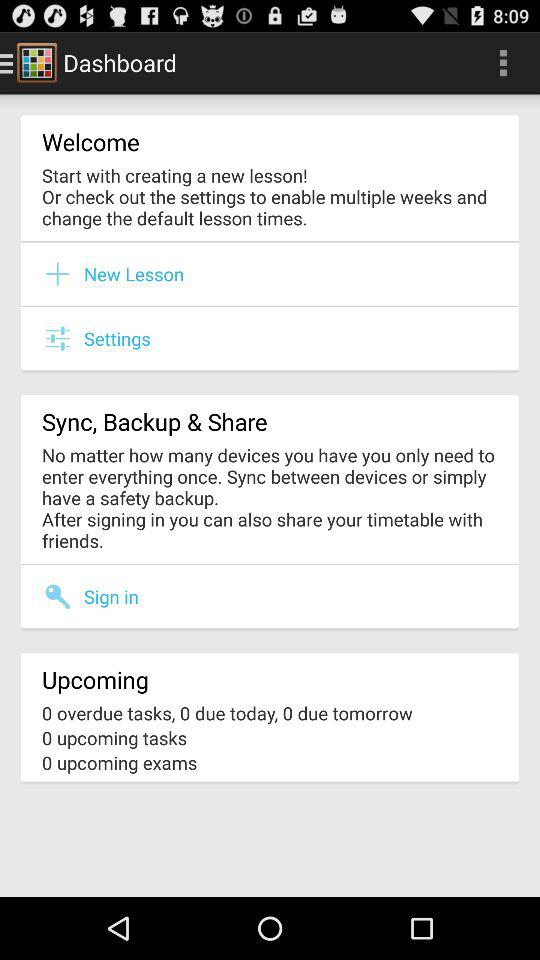How many tasks are due today?
Answer the question using a single word or phrase. 0 